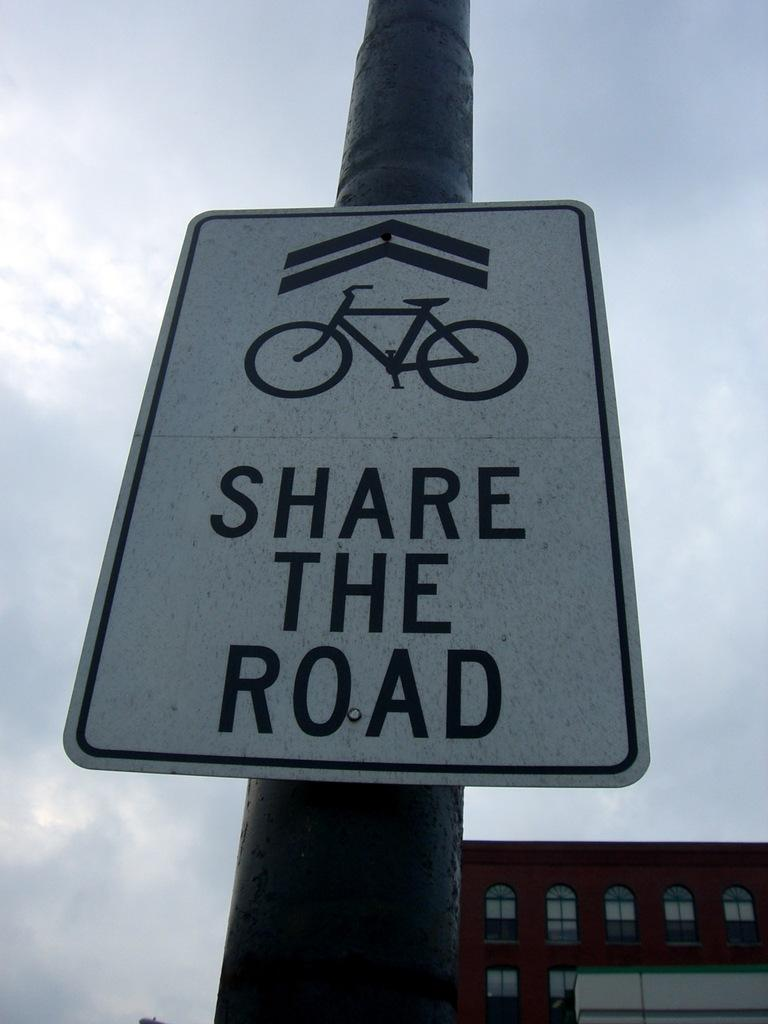What is located on a pole in the image? There is a sign board on a pole in the image. What structure can be seen in the bottom right corner of the image? There is a building in the bottom right corner of the image. What part of the natural environment is visible in the image? The sky is visible in the background of the image. What type of verse can be seen written on the sign board in the image? There is no verse present on the sign board in the image. How many snails are crawling on the building in the image? There are no snails visible in the image; it only features a sign board on a pole and a building in the bottom right corner. 